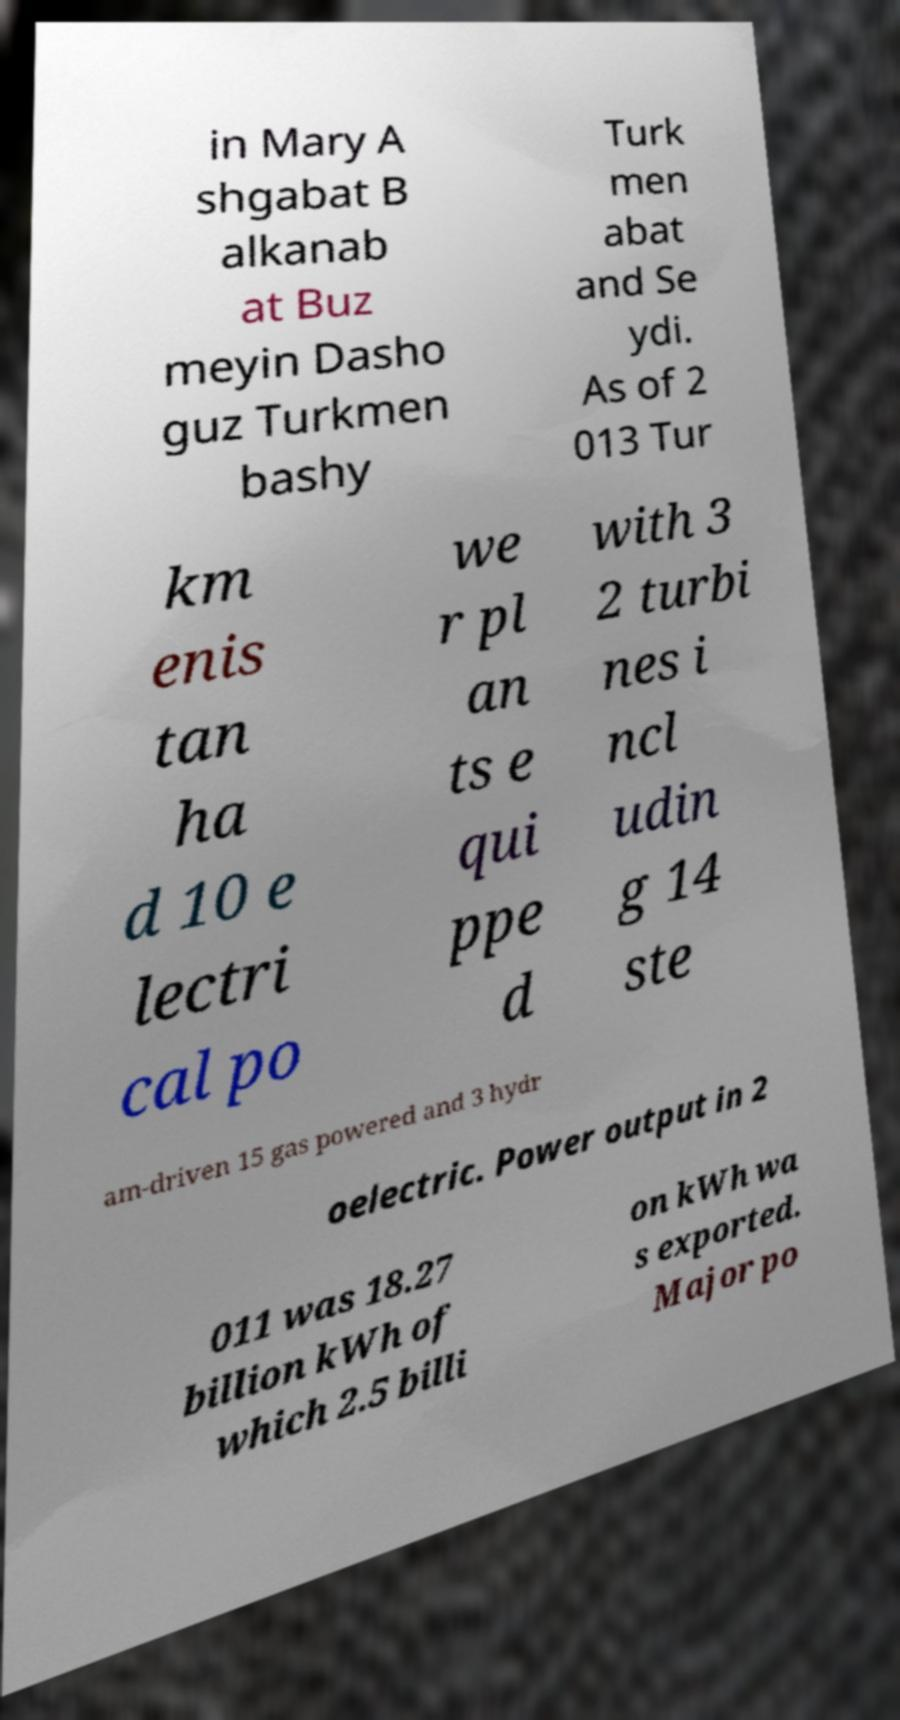Can you read and provide the text displayed in the image?This photo seems to have some interesting text. Can you extract and type it out for me? in Mary A shgabat B alkanab at Buz meyin Dasho guz Turkmen bashy Turk men abat and Se ydi. As of 2 013 Tur km enis tan ha d 10 e lectri cal po we r pl an ts e qui ppe d with 3 2 turbi nes i ncl udin g 14 ste am-driven 15 gas powered and 3 hydr oelectric. Power output in 2 011 was 18.27 billion kWh of which 2.5 billi on kWh wa s exported. Major po 